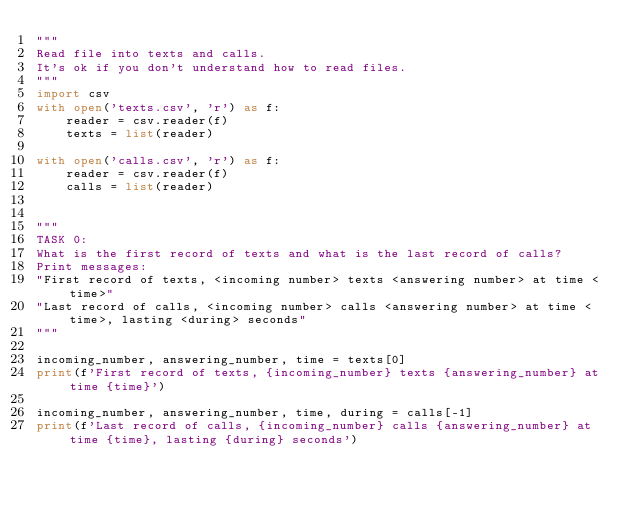Convert code to text. <code><loc_0><loc_0><loc_500><loc_500><_Python_>"""
Read file into texts and calls.
It's ok if you don't understand how to read files.
"""
import csv
with open('texts.csv', 'r') as f:
    reader = csv.reader(f)
    texts = list(reader)

with open('calls.csv', 'r') as f:
    reader = csv.reader(f)
    calls = list(reader)


"""
TASK 0:
What is the first record of texts and what is the last record of calls?
Print messages:
"First record of texts, <incoming number> texts <answering number> at time <time>"
"Last record of calls, <incoming number> calls <answering number> at time <time>, lasting <during> seconds"
"""

incoming_number, answering_number, time = texts[0]
print(f'First record of texts, {incoming_number} texts {answering_number} at time {time}')

incoming_number, answering_number, time, during = calls[-1]
print(f'Last record of calls, {incoming_number} calls {answering_number} at time {time}, lasting {during} seconds')
</code> 